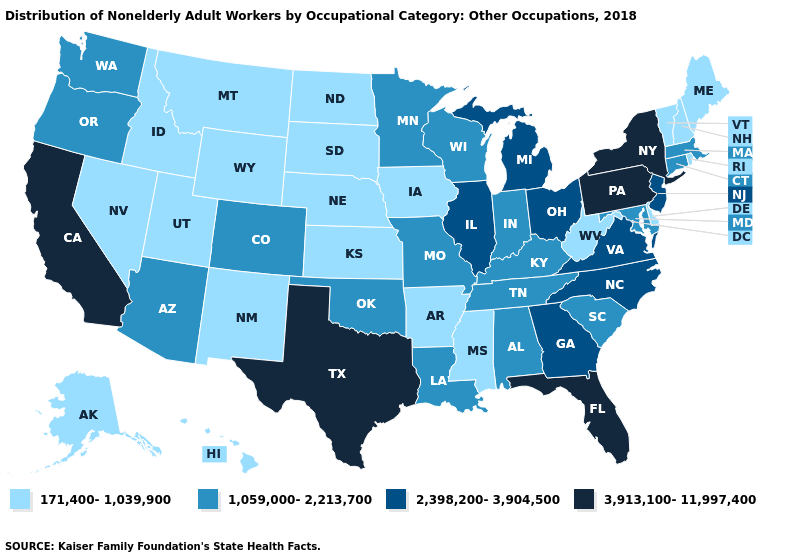Name the states that have a value in the range 2,398,200-3,904,500?
Concise answer only. Georgia, Illinois, Michigan, New Jersey, North Carolina, Ohio, Virginia. Name the states that have a value in the range 171,400-1,039,900?
Be succinct. Alaska, Arkansas, Delaware, Hawaii, Idaho, Iowa, Kansas, Maine, Mississippi, Montana, Nebraska, Nevada, New Hampshire, New Mexico, North Dakota, Rhode Island, South Dakota, Utah, Vermont, West Virginia, Wyoming. What is the value of Minnesota?
Be succinct. 1,059,000-2,213,700. Does the first symbol in the legend represent the smallest category?
Give a very brief answer. Yes. What is the value of New Hampshire?
Short answer required. 171,400-1,039,900. Name the states that have a value in the range 171,400-1,039,900?
Concise answer only. Alaska, Arkansas, Delaware, Hawaii, Idaho, Iowa, Kansas, Maine, Mississippi, Montana, Nebraska, Nevada, New Hampshire, New Mexico, North Dakota, Rhode Island, South Dakota, Utah, Vermont, West Virginia, Wyoming. How many symbols are there in the legend?
Write a very short answer. 4. What is the value of New Hampshire?
Concise answer only. 171,400-1,039,900. Does California have the highest value in the USA?
Be succinct. Yes. What is the value of Hawaii?
Write a very short answer. 171,400-1,039,900. What is the value of New Mexico?
Be succinct. 171,400-1,039,900. Does West Virginia have the lowest value in the South?
Concise answer only. Yes. Name the states that have a value in the range 1,059,000-2,213,700?
Answer briefly. Alabama, Arizona, Colorado, Connecticut, Indiana, Kentucky, Louisiana, Maryland, Massachusetts, Minnesota, Missouri, Oklahoma, Oregon, South Carolina, Tennessee, Washington, Wisconsin. Does Kentucky have the lowest value in the USA?
Answer briefly. No. 